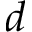Convert formula to latex. <formula><loc_0><loc_0><loc_500><loc_500>d</formula> 